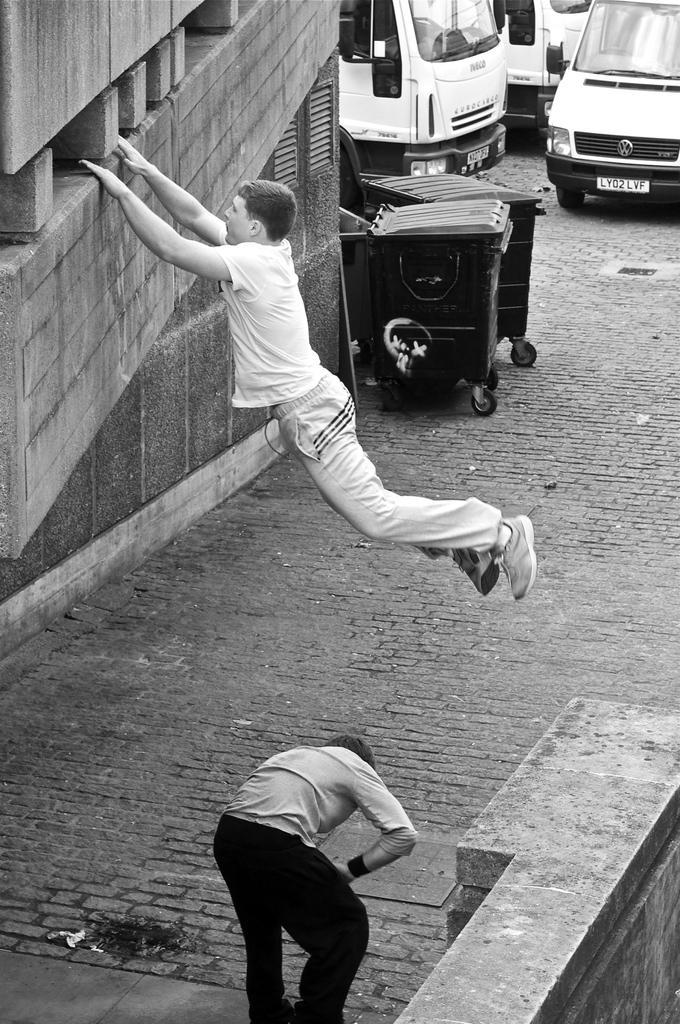In one or two sentences, can you explain what this image depicts? In the foreground, I can see a fence, two persons and a building. In the background, I can see vehicles and some objects on the road. This picture might be taken in a day. 